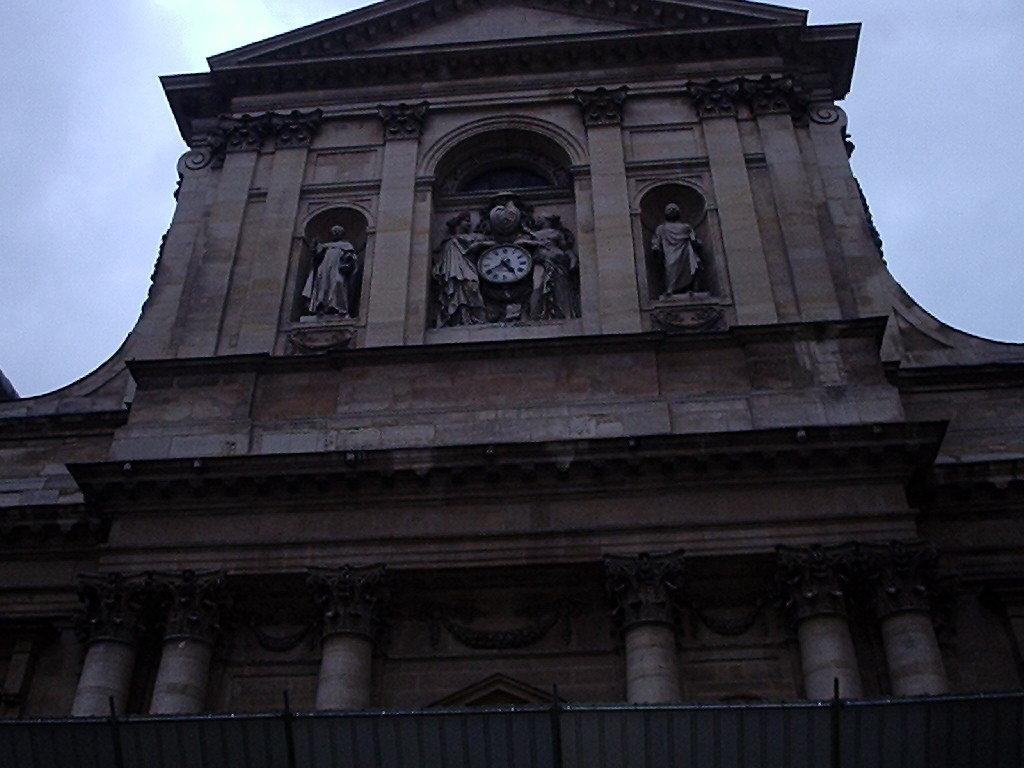What is the main structure in the foreground of the image? There is a building in the foreground of the image. What can be found in the middle of the building? There are sculptures and a clock in the middle of the building. What is visible at the top of the image? The sky is visible at the top of the image. What decision was made by the sculptures in the image? There are no decisions made by the sculptures in the image, as they are inanimate objects. 